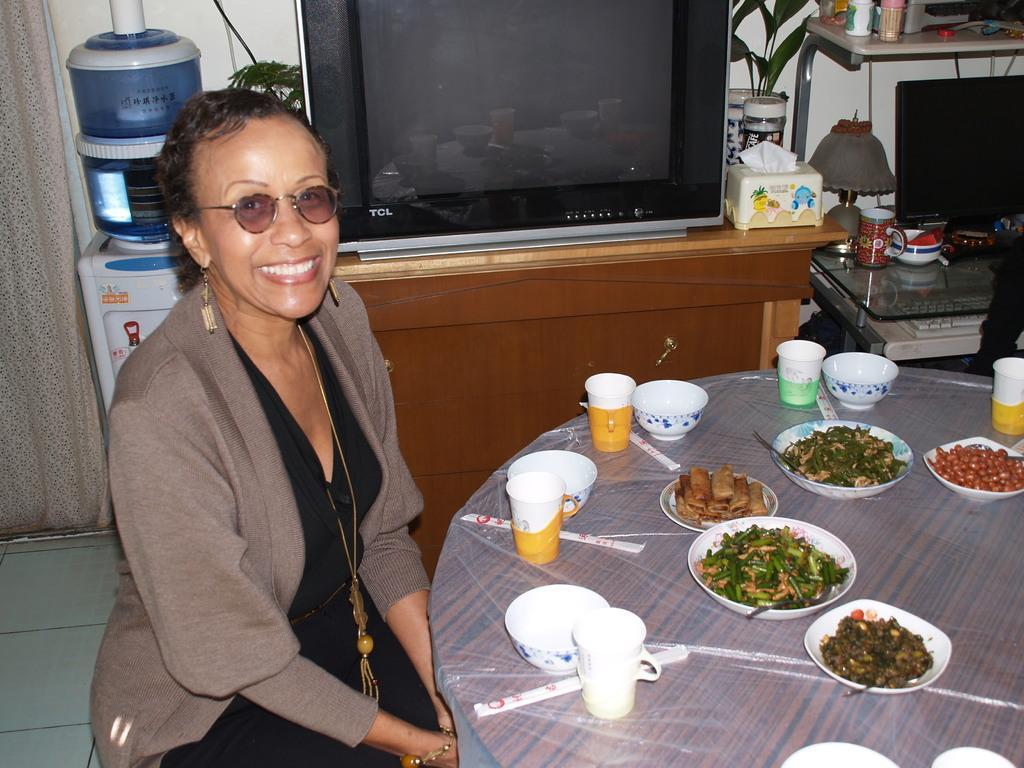Please provide a concise description of this image. There is a lady wearing specs, earrings, chain and bracelet is sitting. In front of her there is a table. On the table there are cups, bowls, plates with food item. In the back there is a table. On that there is a television, tissue holder, bottle, plants. Near to that there is a water purifier. Also there is a curtain. On the right side there is a table with computer, keyboard, table lamp and many other items. 